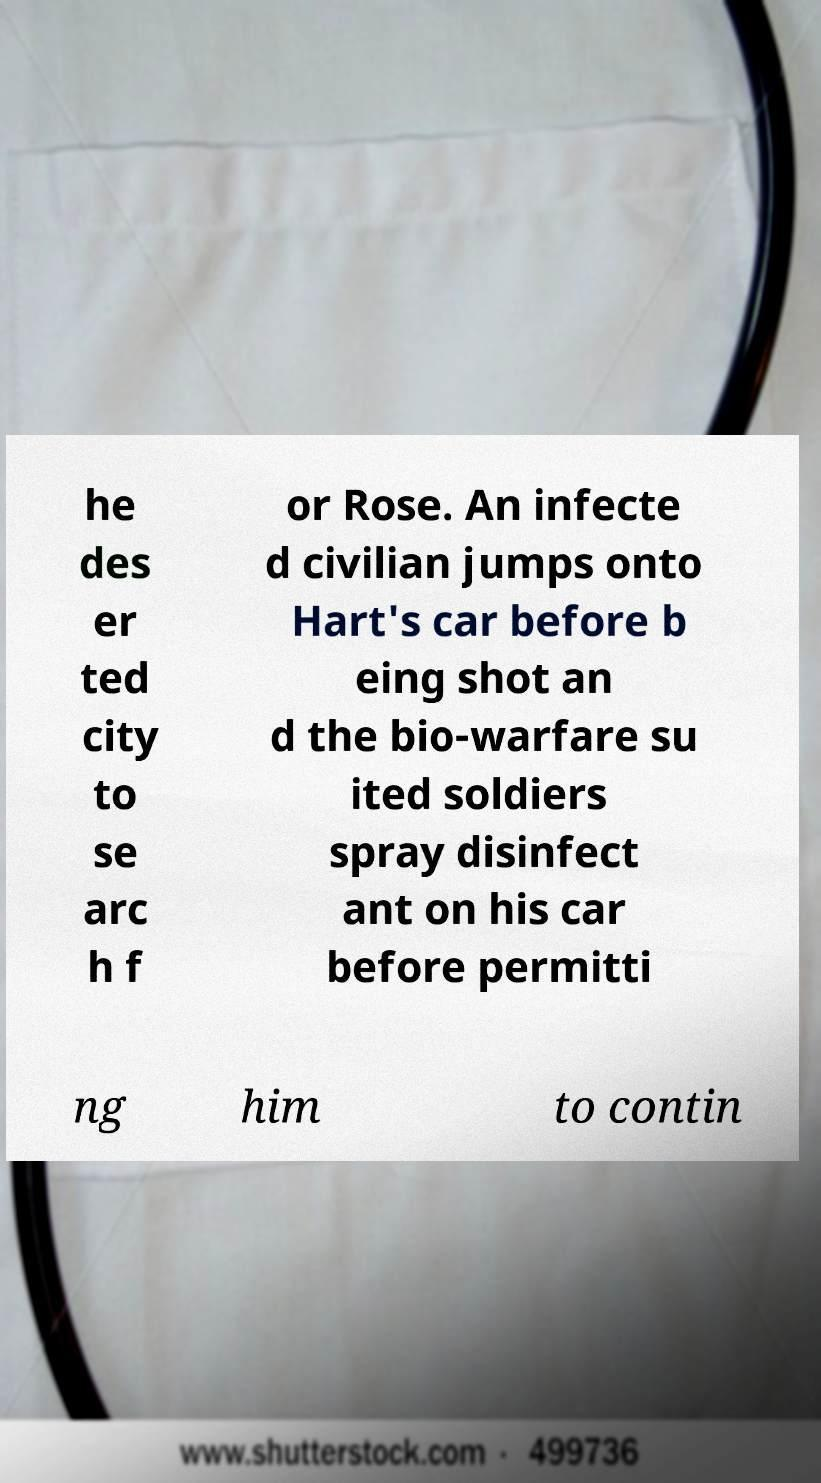I need the written content from this picture converted into text. Can you do that? he des er ted city to se arc h f or Rose. An infecte d civilian jumps onto Hart's car before b eing shot an d the bio-warfare su ited soldiers spray disinfect ant on his car before permitti ng him to contin 